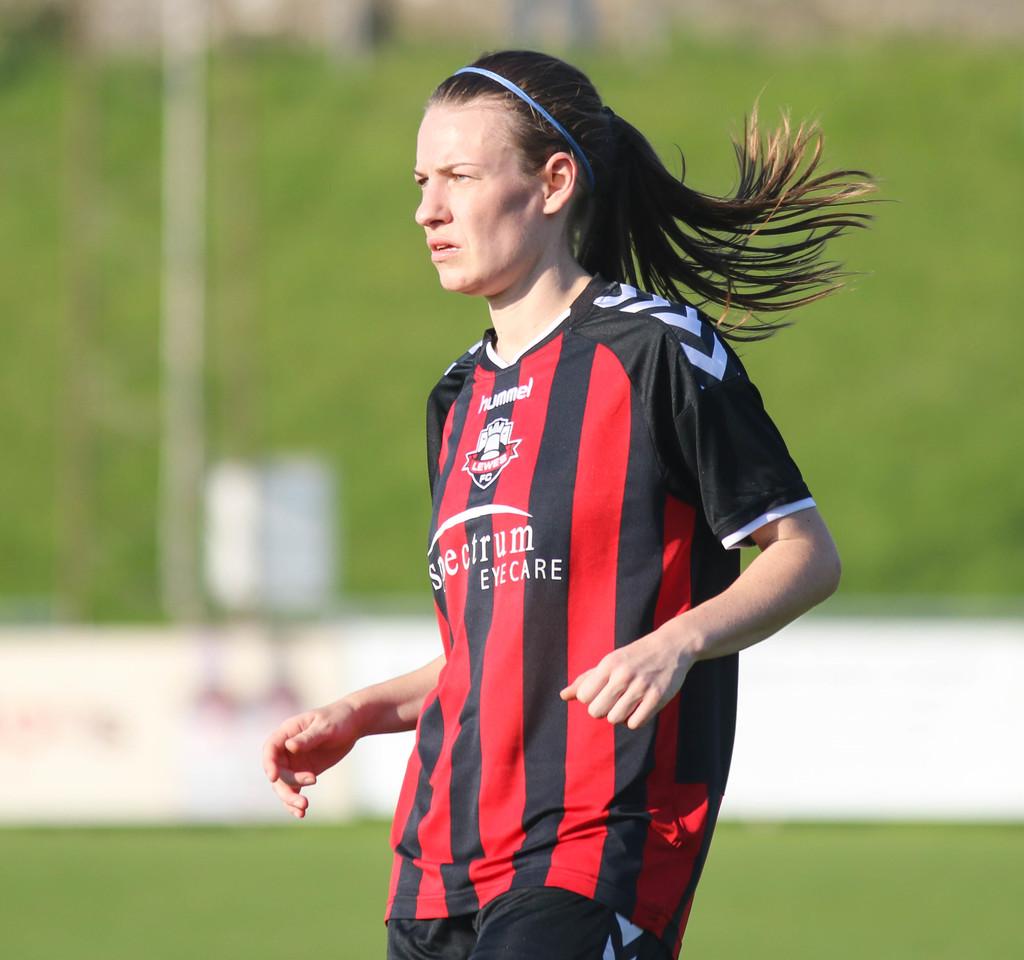What does her jersey say?
Ensure brevity in your answer.  Spectrum eyecare. 